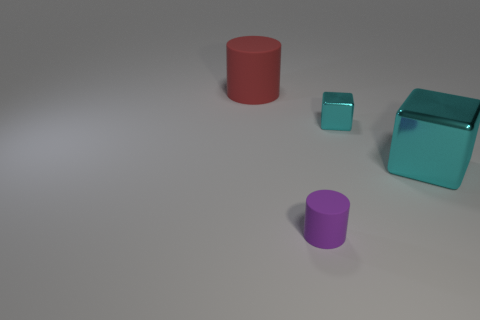Add 2 big cyan blocks. How many objects exist? 6 Subtract 0 green spheres. How many objects are left? 4 Subtract all tiny things. Subtract all big red things. How many objects are left? 1 Add 3 tiny cylinders. How many tiny cylinders are left? 4 Add 2 tiny cyan metallic things. How many tiny cyan metallic things exist? 3 